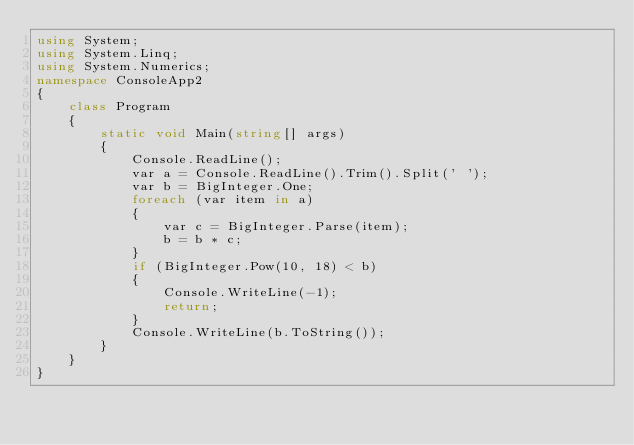<code> <loc_0><loc_0><loc_500><loc_500><_C#_>using System;
using System.Linq;
using System.Numerics;
namespace ConsoleApp2
{
    class Program
    {
        static void Main(string[] args)
        {
            Console.ReadLine();
            var a = Console.ReadLine().Trim().Split(' ');
            var b = BigInteger.One;
            foreach (var item in a)
            {
                var c = BigInteger.Parse(item);
                b = b * c;
            }
            if (BigInteger.Pow(10, 18) < b)
            {
                Console.WriteLine(-1);
                return;
            }
            Console.WriteLine(b.ToString());
        }
    }
}
</code> 